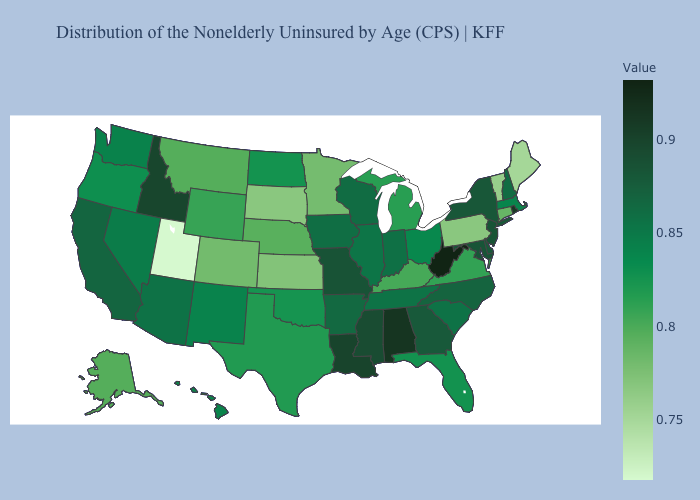Does Minnesota have the highest value in the USA?
Be succinct. No. Which states have the lowest value in the USA?
Concise answer only. Utah. Among the states that border Maryland , does Delaware have the lowest value?
Be succinct. No. 